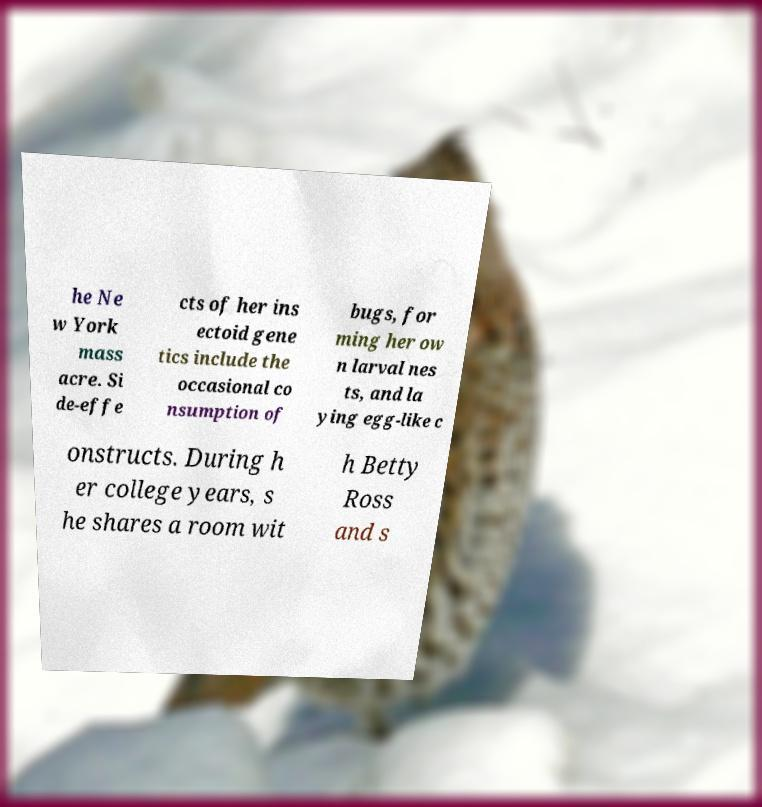There's text embedded in this image that I need extracted. Can you transcribe it verbatim? he Ne w York mass acre. Si de-effe cts of her ins ectoid gene tics include the occasional co nsumption of bugs, for ming her ow n larval nes ts, and la ying egg-like c onstructs. During h er college years, s he shares a room wit h Betty Ross and s 